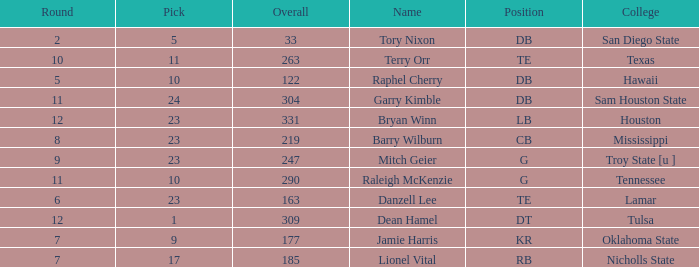Which Round is the highest one that has a Pick smaller than 10, and a Name of tory nixon? 2.0. 